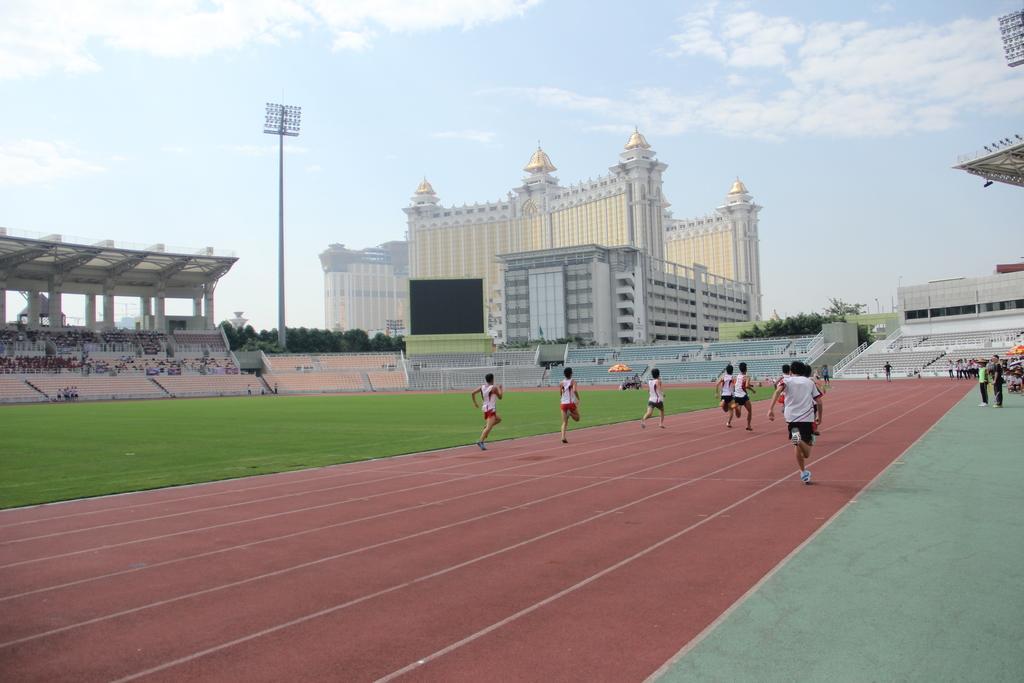Please provide a concise description of this image. In this picture I can see there are some people running in a race in the playground and there are some people standing on the right side and there are audience sitting in the backdrop there is a building and there are trees and the sky is clear. 